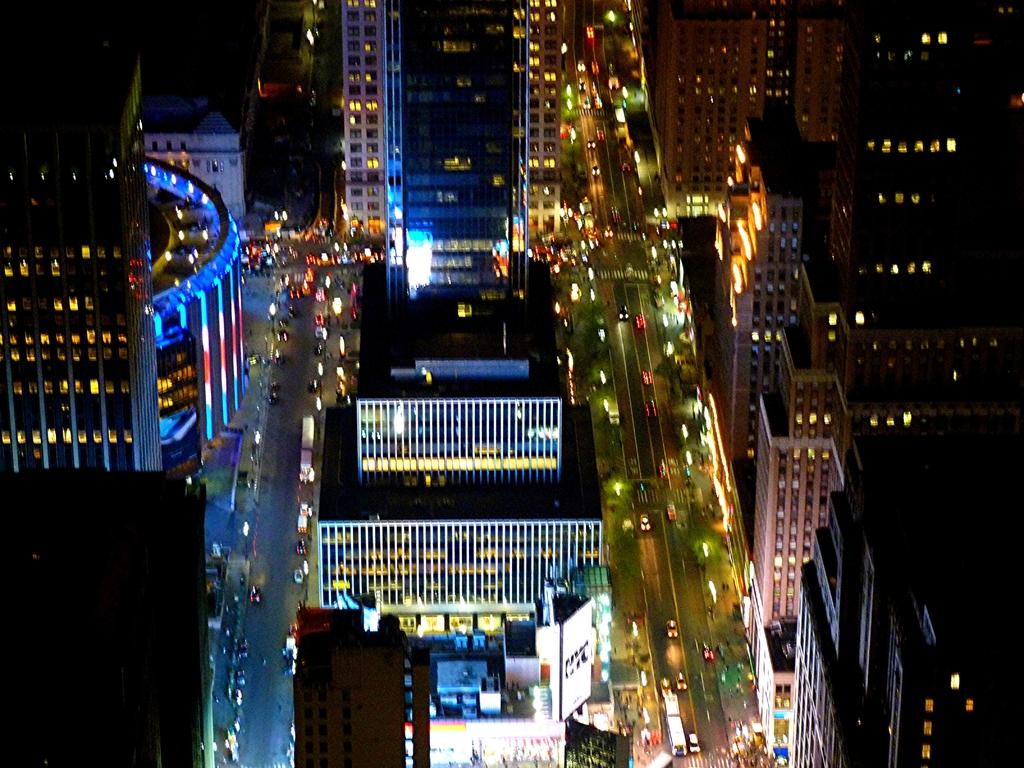What can be seen on the road in the image? There are vehicles on the road in the image. What is visible in the background of the image? There are buildings visible in the background of the image. What type of umbrella is being used by the news reporter in the image? There is no news reporter or umbrella present in the image. How does the edge of the road affect the vehicles in the image? The edge of the road does not affect the vehicles in the image, as it is not mentioned in the provided facts. 